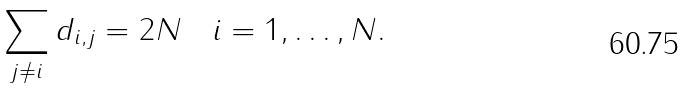<formula> <loc_0><loc_0><loc_500><loc_500>\sum _ { j \not = i } d _ { i , j } = 2 N \quad i = 1 , \dots , N .</formula> 